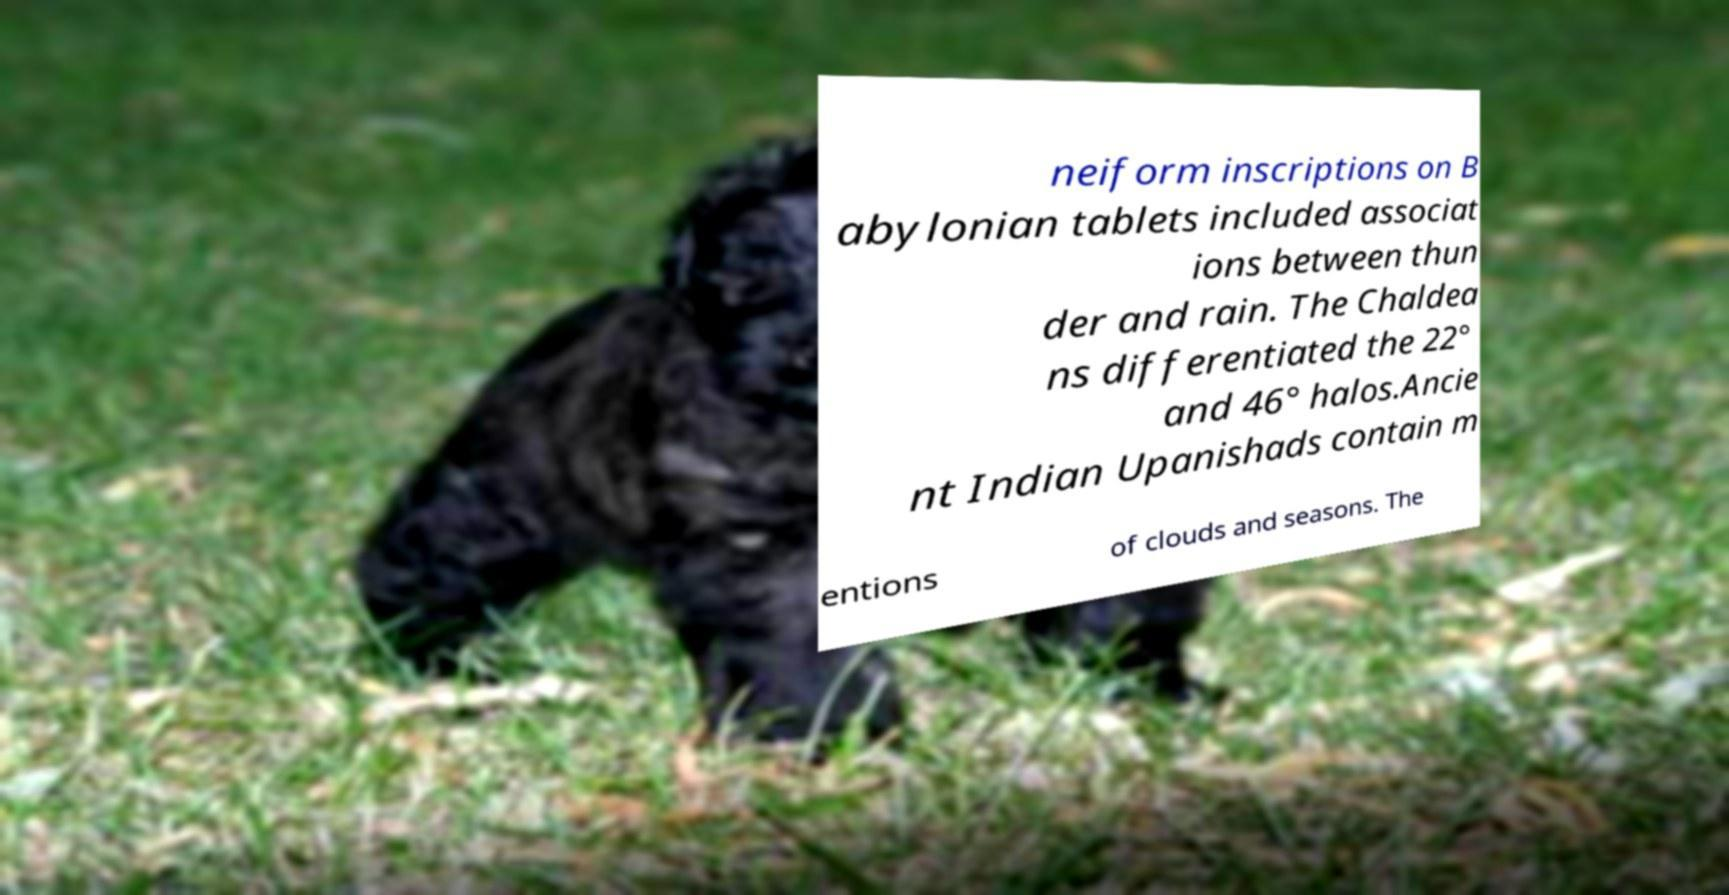I need the written content from this picture converted into text. Can you do that? neiform inscriptions on B abylonian tablets included associat ions between thun der and rain. The Chaldea ns differentiated the 22° and 46° halos.Ancie nt Indian Upanishads contain m entions of clouds and seasons. The 